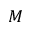<formula> <loc_0><loc_0><loc_500><loc_500>M</formula> 